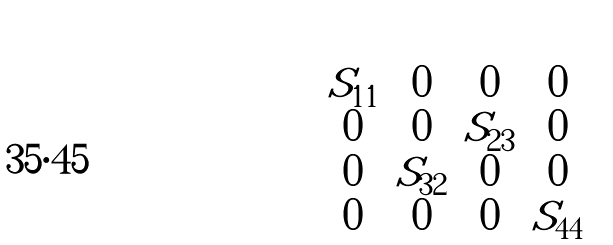Convert formula to latex. <formula><loc_0><loc_0><loc_500><loc_500>\begin{pmatrix} S _ { 1 1 } & 0 & 0 & 0 \\ 0 & 0 & S _ { 2 3 } & 0 \\ 0 & S _ { 3 2 } & 0 & 0 \\ 0 & 0 & 0 & S _ { 4 4 } \end{pmatrix}</formula> 